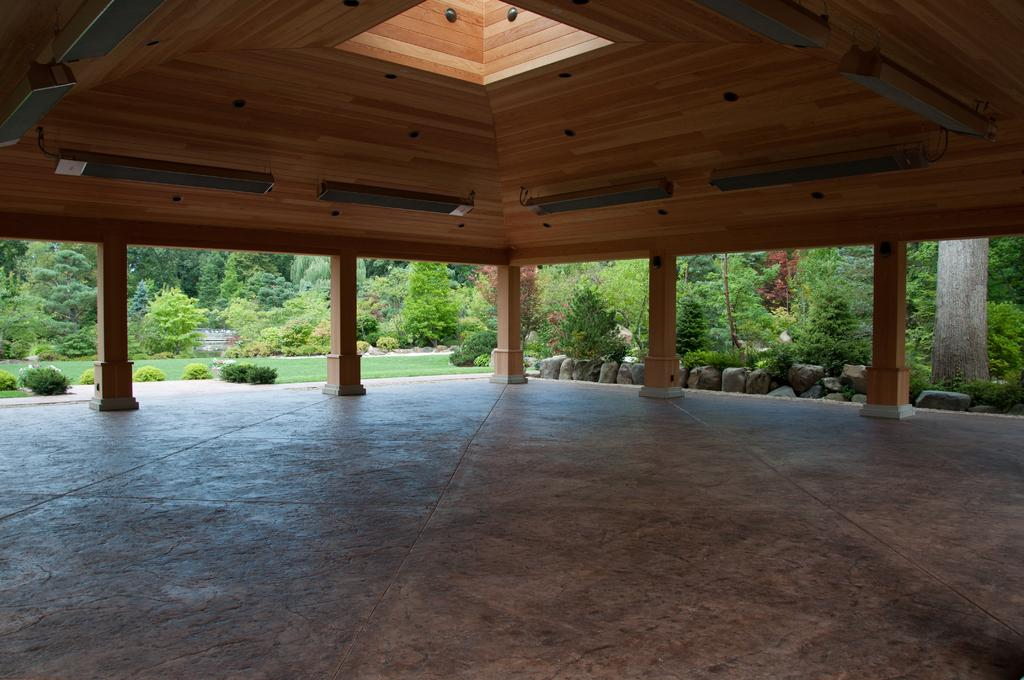What type of structure is present in the image? There is a wooden shelter with pillars in the image. What can be seen beneath the shelter? The floor is visible in the image. What is the natural environment like in the background of the image? There is grassy land, plants, and trees visible in the background of the image. Can you see a snail rolling on the grass in the image? There is no snail present in the image, and therefore no rolling snail can be observed. 